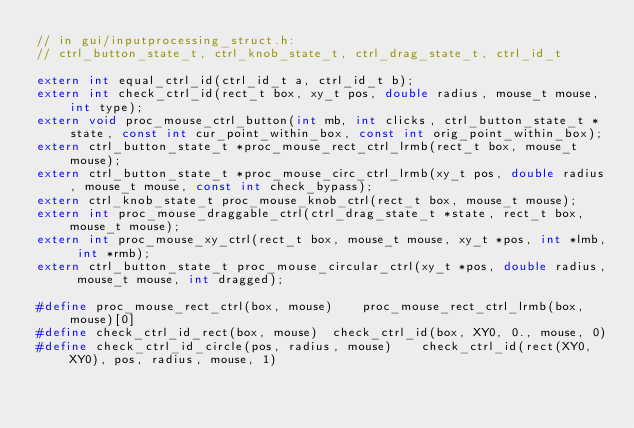<code> <loc_0><loc_0><loc_500><loc_500><_C_>// in gui/inputprocessing_struct.h:
// ctrl_button_state_t, ctrl_knob_state_t, ctrl_drag_state_t, ctrl_id_t

extern int equal_ctrl_id(ctrl_id_t a, ctrl_id_t b);
extern int check_ctrl_id(rect_t box, xy_t pos, double radius, mouse_t mouse, int type);
extern void proc_mouse_ctrl_button(int mb, int clicks, ctrl_button_state_t *state, const int cur_point_within_box, const int orig_point_within_box);
extern ctrl_button_state_t *proc_mouse_rect_ctrl_lrmb(rect_t box, mouse_t mouse);
extern ctrl_button_state_t *proc_mouse_circ_ctrl_lrmb(xy_t pos, double radius, mouse_t mouse, const int check_bypass);
extern ctrl_knob_state_t proc_mouse_knob_ctrl(rect_t box, mouse_t mouse);
extern int proc_mouse_draggable_ctrl(ctrl_drag_state_t *state, rect_t box, mouse_t mouse);
extern int proc_mouse_xy_ctrl(rect_t box, mouse_t mouse, xy_t *pos, int *lmb, int *rmb);
extern ctrl_button_state_t proc_mouse_circular_ctrl(xy_t *pos, double radius, mouse_t mouse, int dragged);

#define proc_mouse_rect_ctrl(box, mouse)	proc_mouse_rect_ctrl_lrmb(box, mouse)[0]
#define check_ctrl_id_rect(box, mouse)	check_ctrl_id(box, XY0, 0., mouse, 0)
#define check_ctrl_id_circle(pos, radius, mouse)	check_ctrl_id(rect(XY0,XY0), pos, radius, mouse, 1)
</code> 